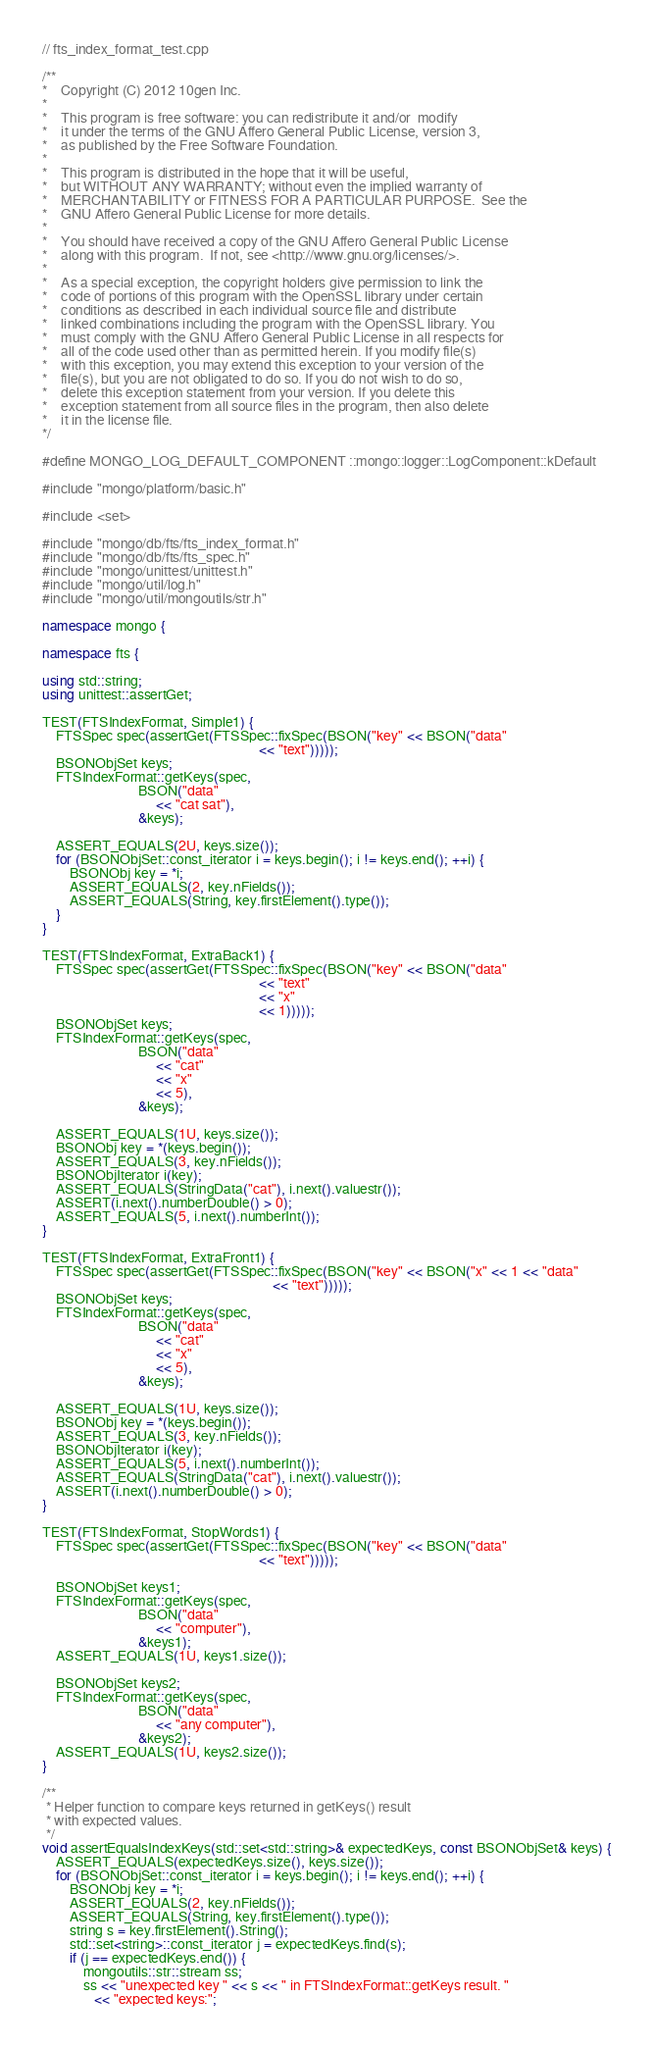<code> <loc_0><loc_0><loc_500><loc_500><_C++_>// fts_index_format_test.cpp

/**
*    Copyright (C) 2012 10gen Inc.
*
*    This program is free software: you can redistribute it and/or  modify
*    it under the terms of the GNU Affero General Public License, version 3,
*    as published by the Free Software Foundation.
*
*    This program is distributed in the hope that it will be useful,
*    but WITHOUT ANY WARRANTY; without even the implied warranty of
*    MERCHANTABILITY or FITNESS FOR A PARTICULAR PURPOSE.  See the
*    GNU Affero General Public License for more details.
*
*    You should have received a copy of the GNU Affero General Public License
*    along with this program.  If not, see <http://www.gnu.org/licenses/>.
*
*    As a special exception, the copyright holders give permission to link the
*    code of portions of this program with the OpenSSL library under certain
*    conditions as described in each individual source file and distribute
*    linked combinations including the program with the OpenSSL library. You
*    must comply with the GNU Affero General Public License in all respects for
*    all of the code used other than as permitted herein. If you modify file(s)
*    with this exception, you may extend this exception to your version of the
*    file(s), but you are not obligated to do so. If you do not wish to do so,
*    delete this exception statement from your version. If you delete this
*    exception statement from all source files in the program, then also delete
*    it in the license file.
*/

#define MONGO_LOG_DEFAULT_COMPONENT ::mongo::logger::LogComponent::kDefault

#include "mongo/platform/basic.h"

#include <set>

#include "mongo/db/fts/fts_index_format.h"
#include "mongo/db/fts/fts_spec.h"
#include "mongo/unittest/unittest.h"
#include "mongo/util/log.h"
#include "mongo/util/mongoutils/str.h"

namespace mongo {

namespace fts {

using std::string;
using unittest::assertGet;

TEST(FTSIndexFormat, Simple1) {
    FTSSpec spec(assertGet(FTSSpec::fixSpec(BSON("key" << BSON("data"
                                                               << "text")))));
    BSONObjSet keys;
    FTSIndexFormat::getKeys(spec,
                            BSON("data"
                                 << "cat sat"),
                            &keys);

    ASSERT_EQUALS(2U, keys.size());
    for (BSONObjSet::const_iterator i = keys.begin(); i != keys.end(); ++i) {
        BSONObj key = *i;
        ASSERT_EQUALS(2, key.nFields());
        ASSERT_EQUALS(String, key.firstElement().type());
    }
}

TEST(FTSIndexFormat, ExtraBack1) {
    FTSSpec spec(assertGet(FTSSpec::fixSpec(BSON("key" << BSON("data"
                                                               << "text"
                                                               << "x"
                                                               << 1)))));
    BSONObjSet keys;
    FTSIndexFormat::getKeys(spec,
                            BSON("data"
                                 << "cat"
                                 << "x"
                                 << 5),
                            &keys);

    ASSERT_EQUALS(1U, keys.size());
    BSONObj key = *(keys.begin());
    ASSERT_EQUALS(3, key.nFields());
    BSONObjIterator i(key);
    ASSERT_EQUALS(StringData("cat"), i.next().valuestr());
    ASSERT(i.next().numberDouble() > 0);
    ASSERT_EQUALS(5, i.next().numberInt());
}

TEST(FTSIndexFormat, ExtraFront1) {
    FTSSpec spec(assertGet(FTSSpec::fixSpec(BSON("key" << BSON("x" << 1 << "data"
                                                                   << "text")))));
    BSONObjSet keys;
    FTSIndexFormat::getKeys(spec,
                            BSON("data"
                                 << "cat"
                                 << "x"
                                 << 5),
                            &keys);

    ASSERT_EQUALS(1U, keys.size());
    BSONObj key = *(keys.begin());
    ASSERT_EQUALS(3, key.nFields());
    BSONObjIterator i(key);
    ASSERT_EQUALS(5, i.next().numberInt());
    ASSERT_EQUALS(StringData("cat"), i.next().valuestr());
    ASSERT(i.next().numberDouble() > 0);
}

TEST(FTSIndexFormat, StopWords1) {
    FTSSpec spec(assertGet(FTSSpec::fixSpec(BSON("key" << BSON("data"
                                                               << "text")))));

    BSONObjSet keys1;
    FTSIndexFormat::getKeys(spec,
                            BSON("data"
                                 << "computer"),
                            &keys1);
    ASSERT_EQUALS(1U, keys1.size());

    BSONObjSet keys2;
    FTSIndexFormat::getKeys(spec,
                            BSON("data"
                                 << "any computer"),
                            &keys2);
    ASSERT_EQUALS(1U, keys2.size());
}

/**
 * Helper function to compare keys returned in getKeys() result
 * with expected values.
 */
void assertEqualsIndexKeys(std::set<std::string>& expectedKeys, const BSONObjSet& keys) {
    ASSERT_EQUALS(expectedKeys.size(), keys.size());
    for (BSONObjSet::const_iterator i = keys.begin(); i != keys.end(); ++i) {
        BSONObj key = *i;
        ASSERT_EQUALS(2, key.nFields());
        ASSERT_EQUALS(String, key.firstElement().type());
        string s = key.firstElement().String();
        std::set<string>::const_iterator j = expectedKeys.find(s);
        if (j == expectedKeys.end()) {
            mongoutils::str::stream ss;
            ss << "unexpected key " << s << " in FTSIndexFormat::getKeys result. "
               << "expected keys:";</code> 